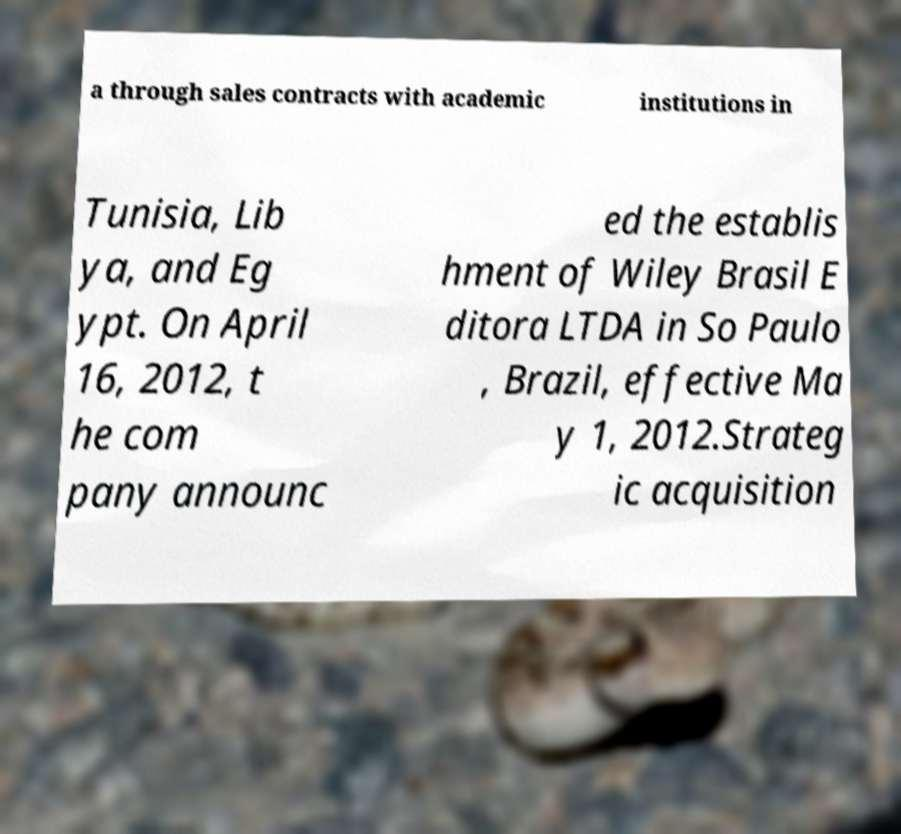Can you read and provide the text displayed in the image?This photo seems to have some interesting text. Can you extract and type it out for me? a through sales contracts with academic institutions in Tunisia, Lib ya, and Eg ypt. On April 16, 2012, t he com pany announc ed the establis hment of Wiley Brasil E ditora LTDA in So Paulo , Brazil, effective Ma y 1, 2012.Strateg ic acquisition 